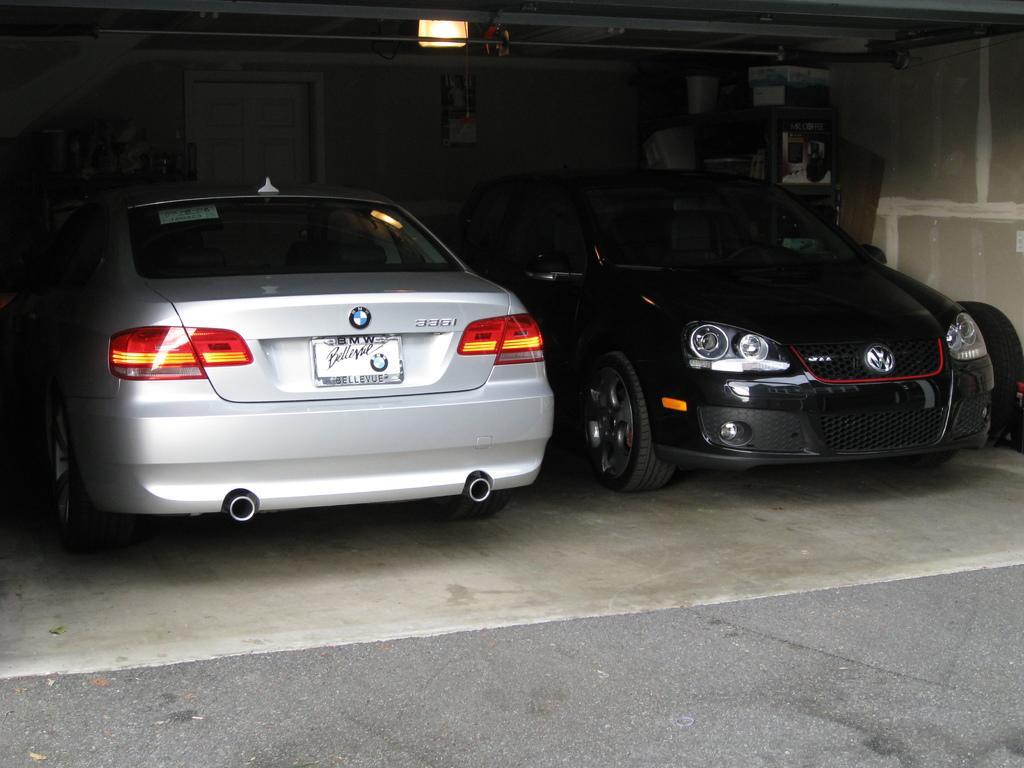Can you describe this image briefly? In the picture I can see cars on the ground. These cars are black and white in color. In the background I can see light and some other objects. 